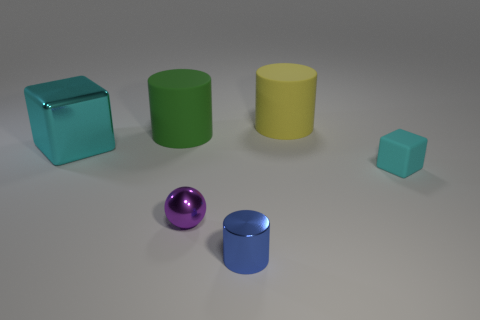Is there any other thing that is the same shape as the purple metallic object?
Your answer should be compact. No. Does the big cyan object have the same material as the large cylinder that is on the right side of the shiny cylinder?
Provide a succinct answer. No. There is a cube to the right of the tiny blue metallic thing; does it have the same color as the metal cube?
Offer a very short reply. Yes. What number of matte objects are right of the green rubber object and in front of the large yellow cylinder?
Keep it short and to the point. 1. What number of other objects are the same material as the small blue cylinder?
Provide a succinct answer. 2. Is the material of the large cylinder that is behind the green cylinder the same as the blue cylinder?
Offer a terse response. No. There is a matte thing that is in front of the large cylinder that is in front of the large yellow matte thing right of the tiny purple object; what is its size?
Make the answer very short. Small. What number of other objects are the same color as the metal cylinder?
Your answer should be compact. 0. The other matte object that is the same size as the purple thing is what shape?
Give a very brief answer. Cube. There is a cylinder that is in front of the purple metallic thing; what is its size?
Make the answer very short. Small. 